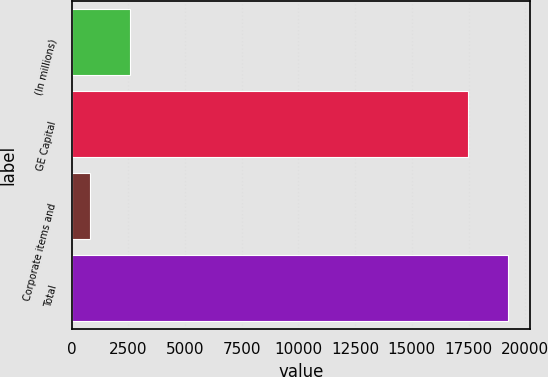Convert chart. <chart><loc_0><loc_0><loc_500><loc_500><bar_chart><fcel>(In millions)<fcel>GE Capital<fcel>Corporate items and<fcel>Total<nl><fcel>2567.1<fcel>17491<fcel>818<fcel>19240.1<nl></chart> 